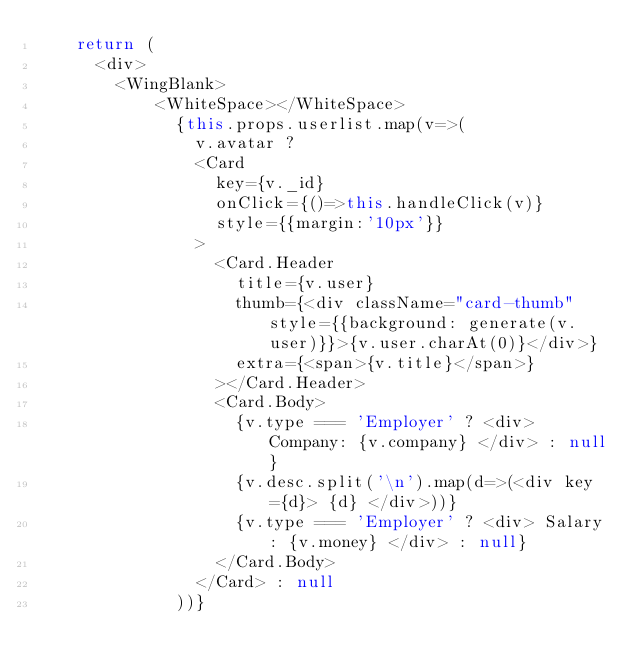<code> <loc_0><loc_0><loc_500><loc_500><_JavaScript_>    return (
      <div>
        <WingBlank>
            <WhiteSpace></WhiteSpace>
              {this.props.userlist.map(v=>(
                v.avatar ?
                <Card 
                  key={v._id} 
                  onClick={()=>this.handleClick(v)}
                  style={{margin:'10px'}}
                >
                  <Card.Header
                    title={v.user}
                    thumb={<div className="card-thumb" style={{background: generate(v.user)}}>{v.user.charAt(0)}</div>}
                    extra={<span>{v.title}</span>}
                  ></Card.Header>
                  <Card.Body>
                    {v.type === 'Employer' ? <div> Company: {v.company} </div> : null}
                    {v.desc.split('\n').map(d=>(<div key={d}> {d} </div>))}
                    {v.type === 'Employer' ? <div> Salary: {v.money} </div> : null}
                  </Card.Body>
                </Card> : null
              ))}</code> 